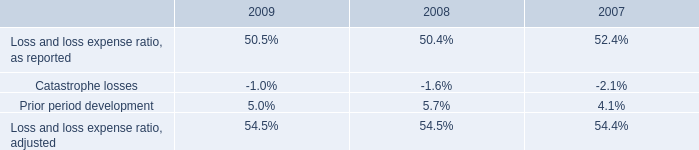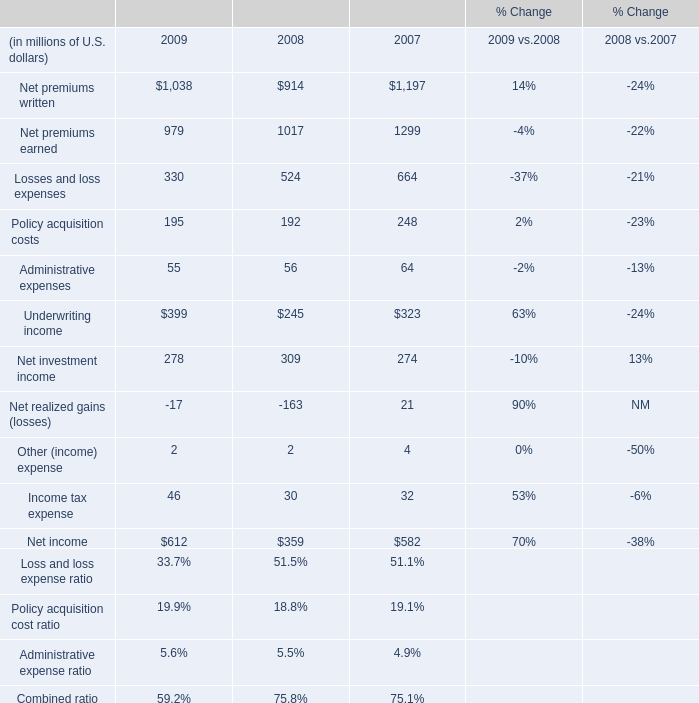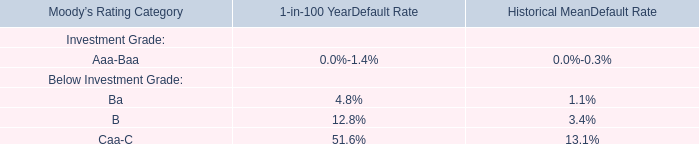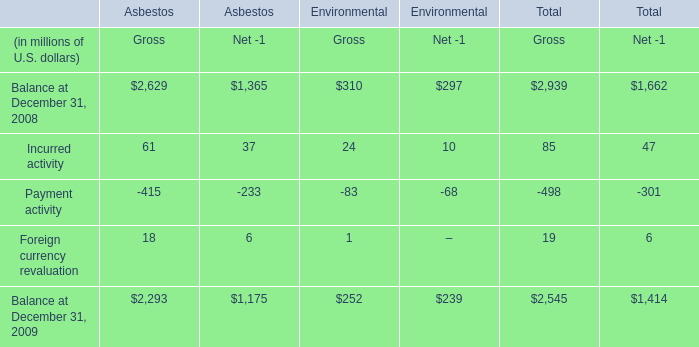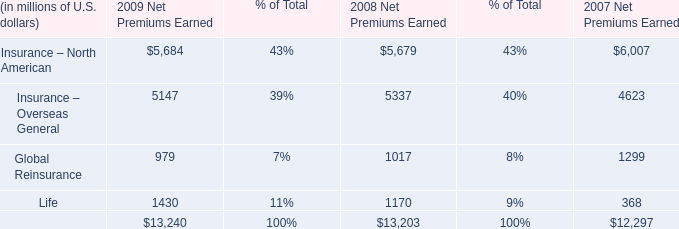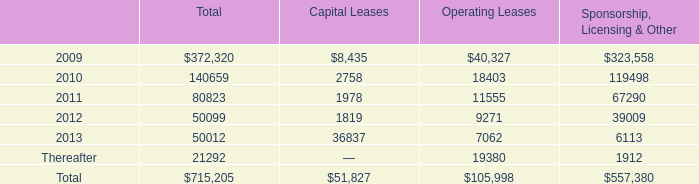what was the average consolidated rental expense from 2006 to 2008 
Computations: (((31467 + (42905 + 35614)) + 3) / 2)
Answer: 54994.5. 